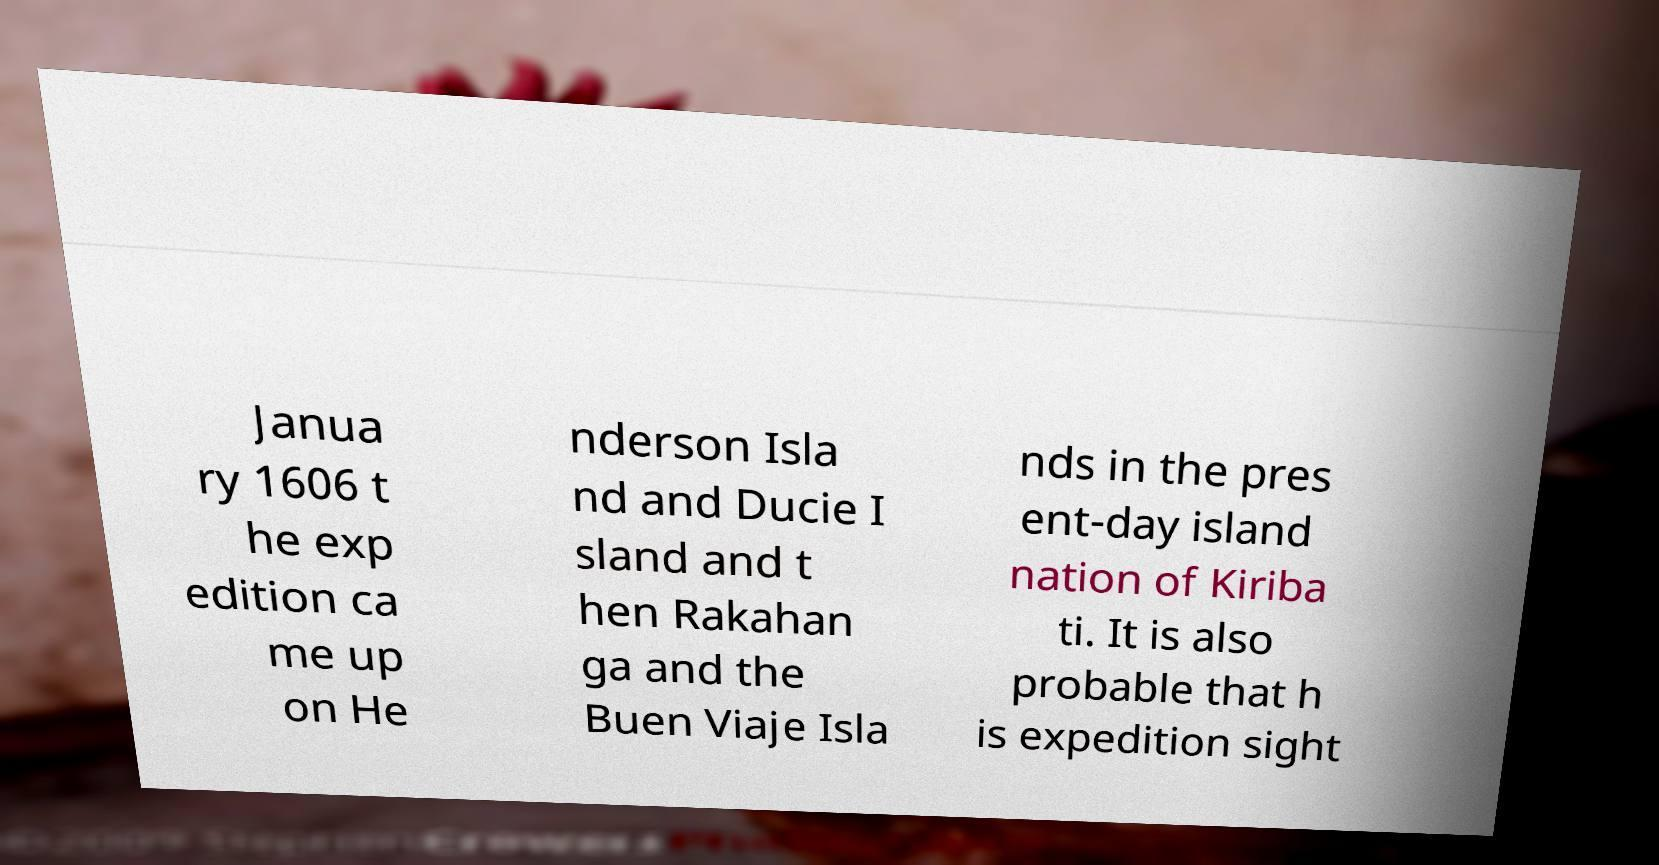For documentation purposes, I need the text within this image transcribed. Could you provide that? Janua ry 1606 t he exp edition ca me up on He nderson Isla nd and Ducie I sland and t hen Rakahan ga and the Buen Viaje Isla nds in the pres ent-day island nation of Kiriba ti. It is also probable that h is expedition sight 